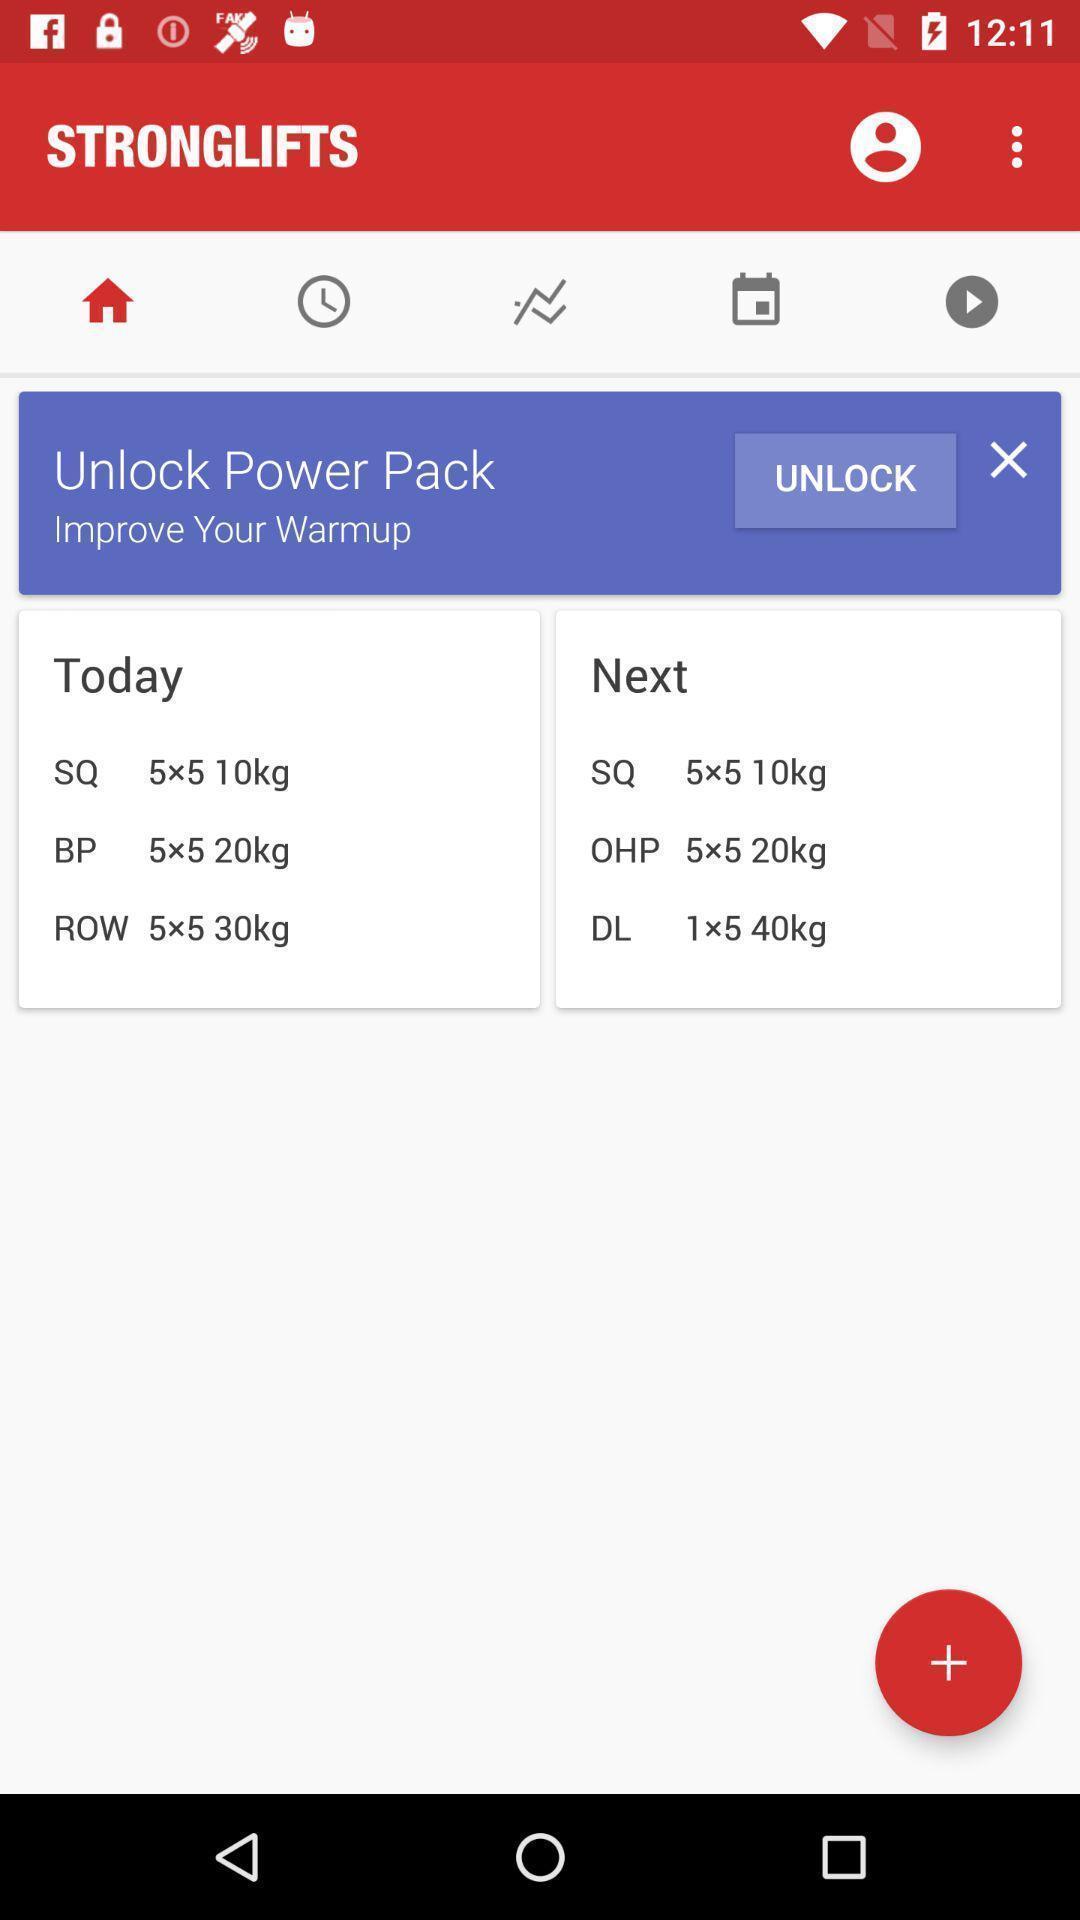What details can you identify in this image? Tab to unblock the power pack in the application. 